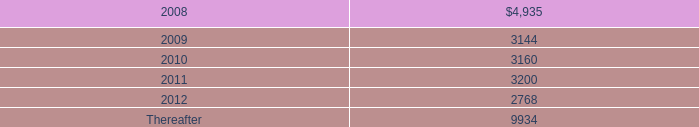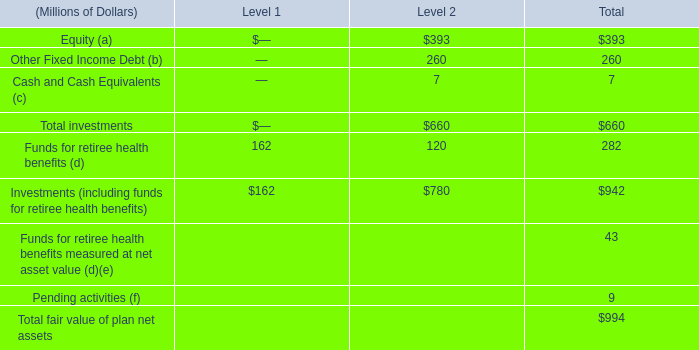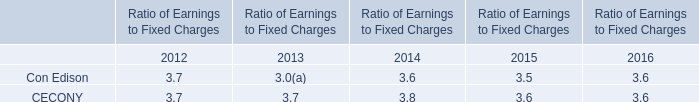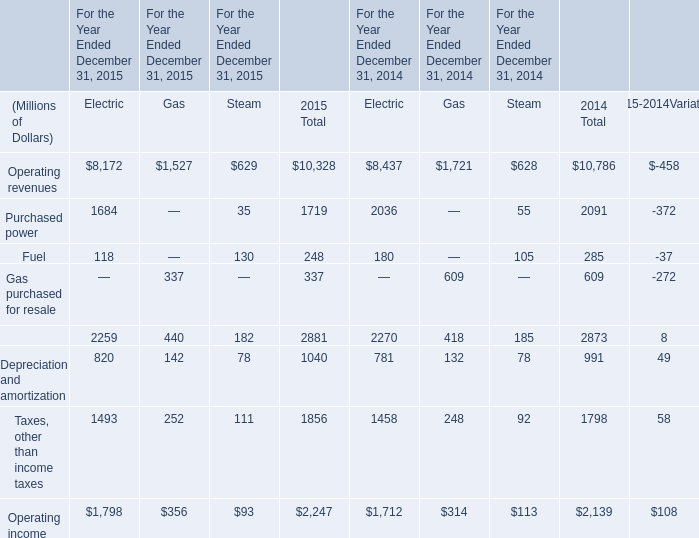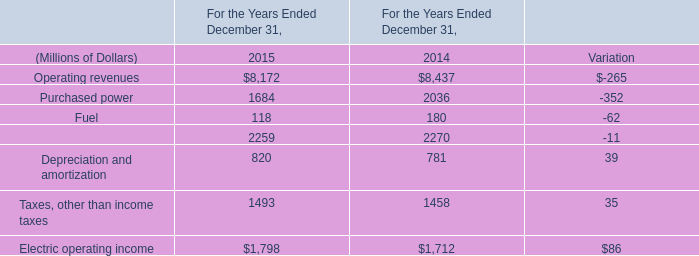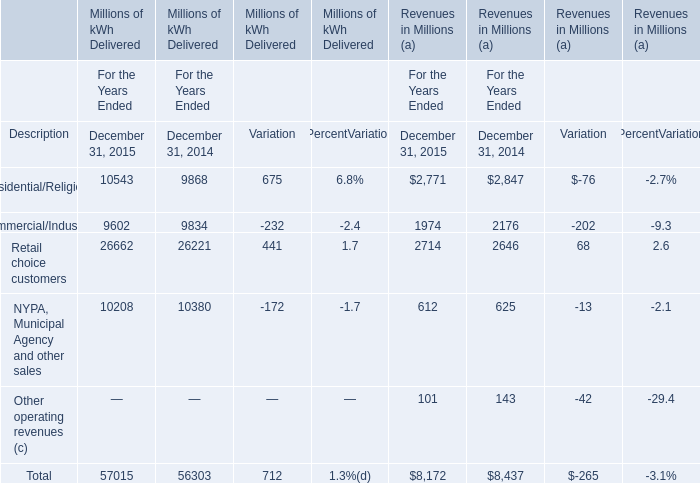If Total of Millions of kWh Delivered develops with the same growth rate in 2015, what will it reach in 2016? (in million) 
Computations: (57015 * (1 + ((57015 - 56303) / 56303)))
Answer: 57736.00385. 